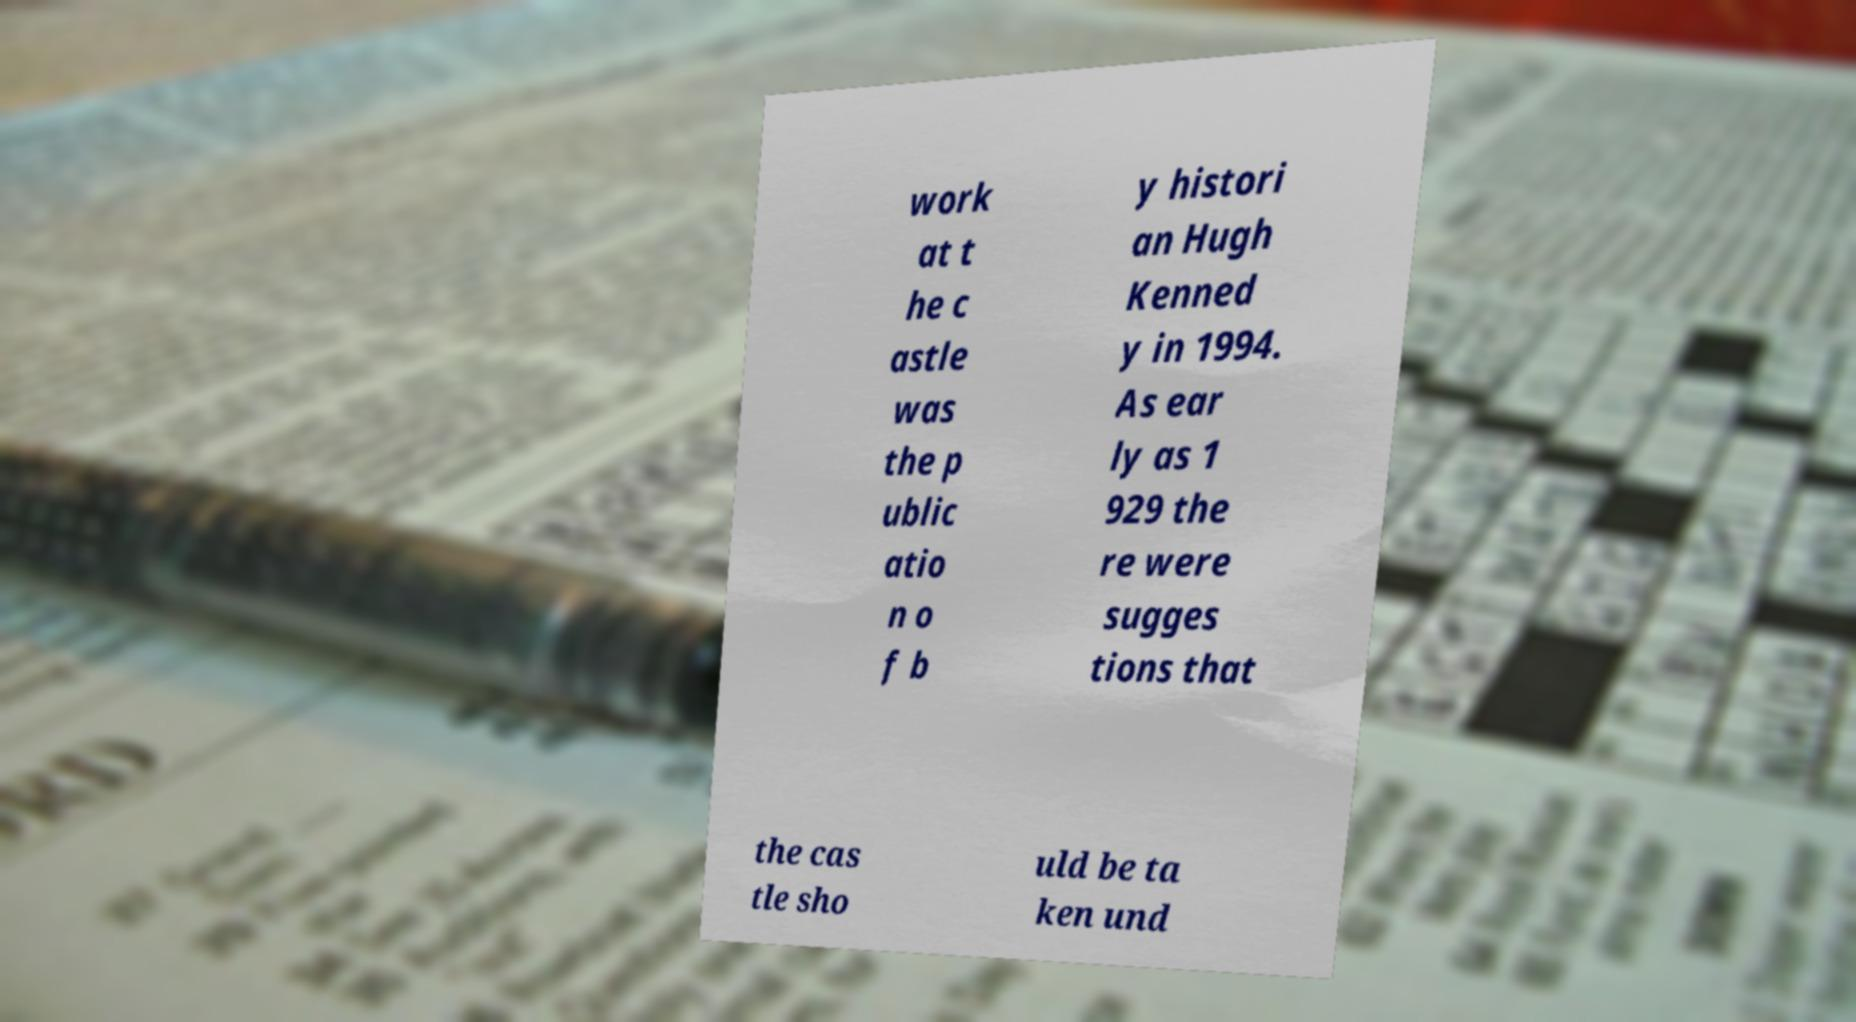Could you assist in decoding the text presented in this image and type it out clearly? work at t he c astle was the p ublic atio n o f b y histori an Hugh Kenned y in 1994. As ear ly as 1 929 the re were sugges tions that the cas tle sho uld be ta ken und 